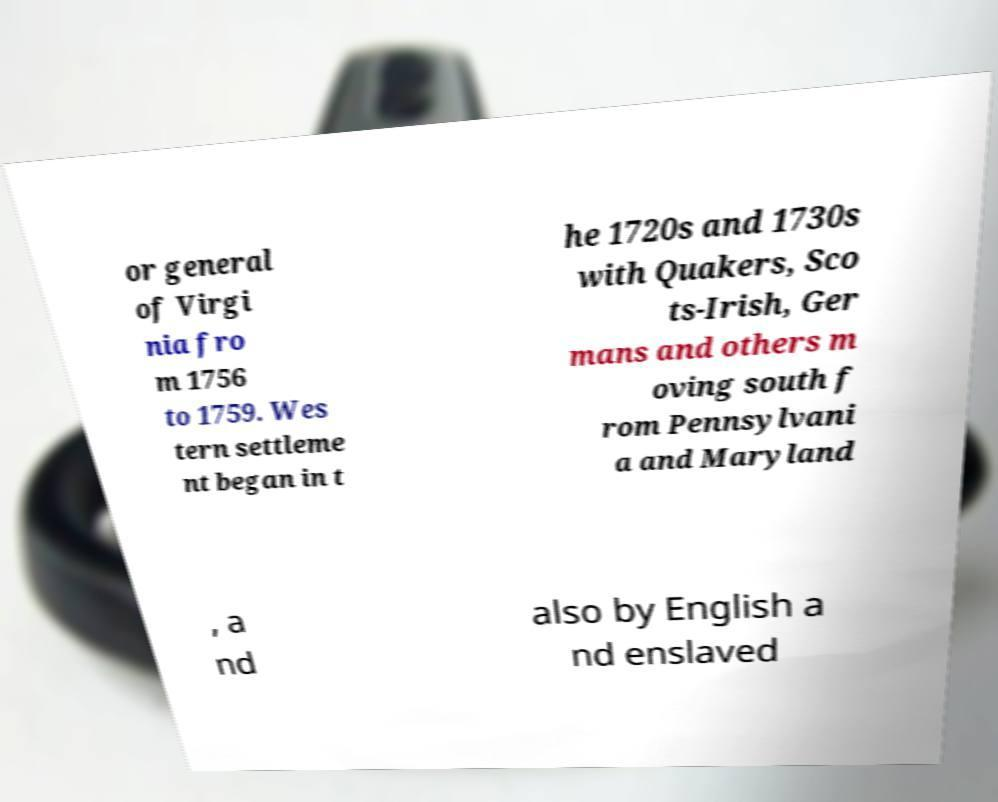Could you assist in decoding the text presented in this image and type it out clearly? or general of Virgi nia fro m 1756 to 1759. Wes tern settleme nt began in t he 1720s and 1730s with Quakers, Sco ts-Irish, Ger mans and others m oving south f rom Pennsylvani a and Maryland , a nd also by English a nd enslaved 